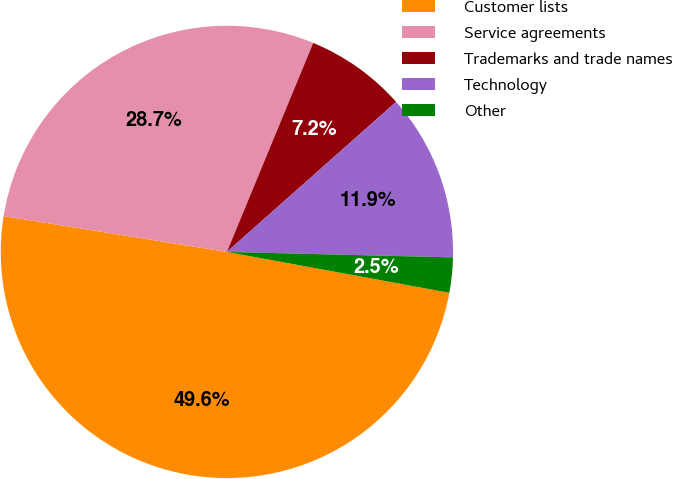<chart> <loc_0><loc_0><loc_500><loc_500><pie_chart><fcel>Customer lists<fcel>Service agreements<fcel>Trademarks and trade names<fcel>Technology<fcel>Other<nl><fcel>49.64%<fcel>28.7%<fcel>7.22%<fcel>11.93%<fcel>2.51%<nl></chart> 